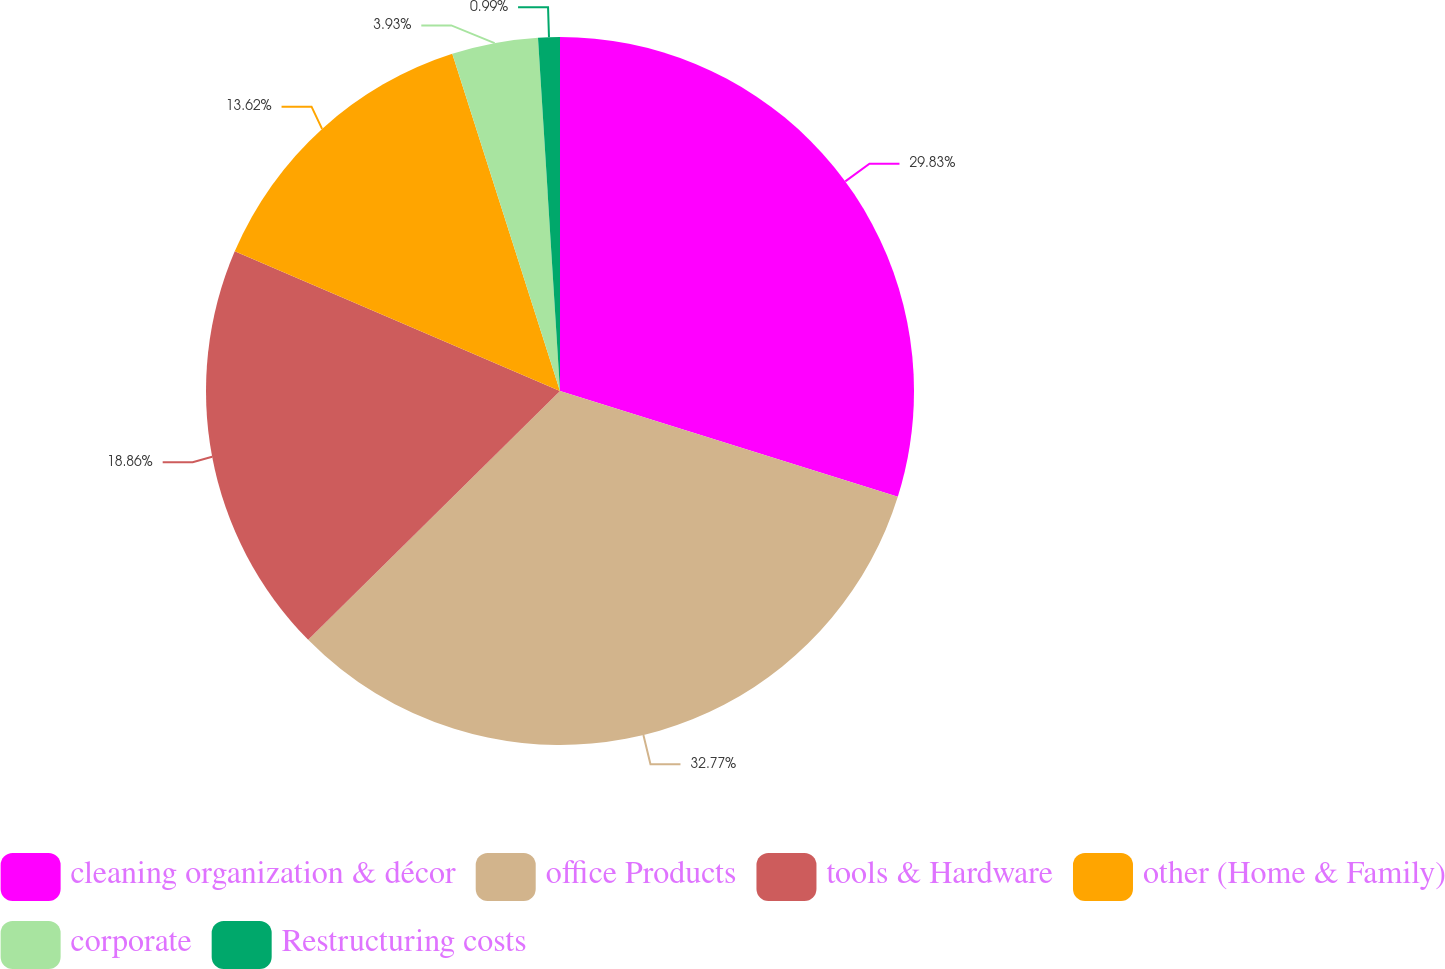Convert chart to OTSL. <chart><loc_0><loc_0><loc_500><loc_500><pie_chart><fcel>cleaning organization & décor<fcel>office Products<fcel>tools & Hardware<fcel>other (Home & Family)<fcel>corporate<fcel>Restructuring costs<nl><fcel>29.83%<fcel>32.76%<fcel>18.86%<fcel>13.62%<fcel>3.93%<fcel>0.99%<nl></chart> 